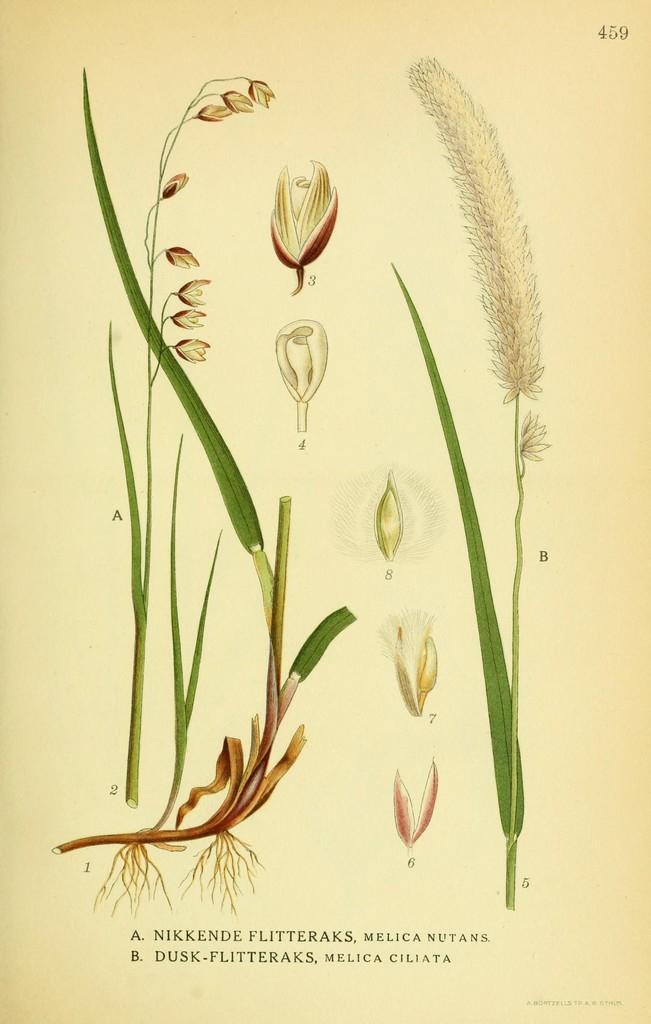In one or two sentences, can you explain what this image depicts? This is a paper. I can see the picture of the plants with leaves, flowers, stems and roots. I think these are the flower buds. I can see the letters in the paper. 